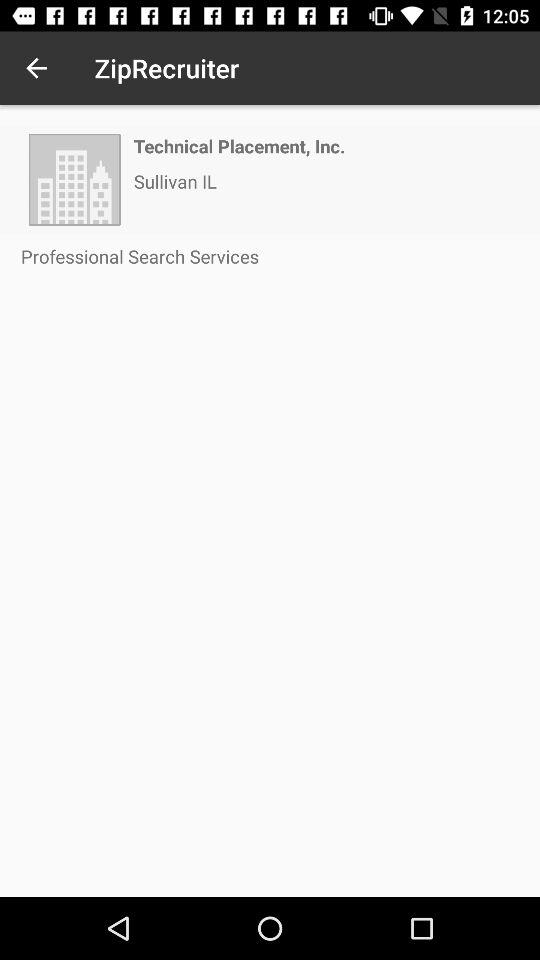What is the shown company name? The shown company name is "Technical Placement, Inc.". 